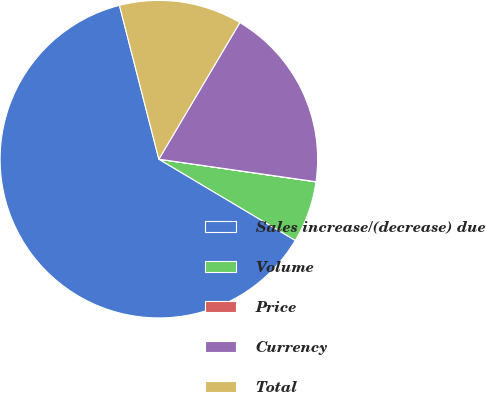<chart> <loc_0><loc_0><loc_500><loc_500><pie_chart><fcel>Sales increase/(decrease) due<fcel>Volume<fcel>Price<fcel>Currency<fcel>Total<nl><fcel>62.46%<fcel>6.26%<fcel>0.02%<fcel>18.75%<fcel>12.51%<nl></chart> 